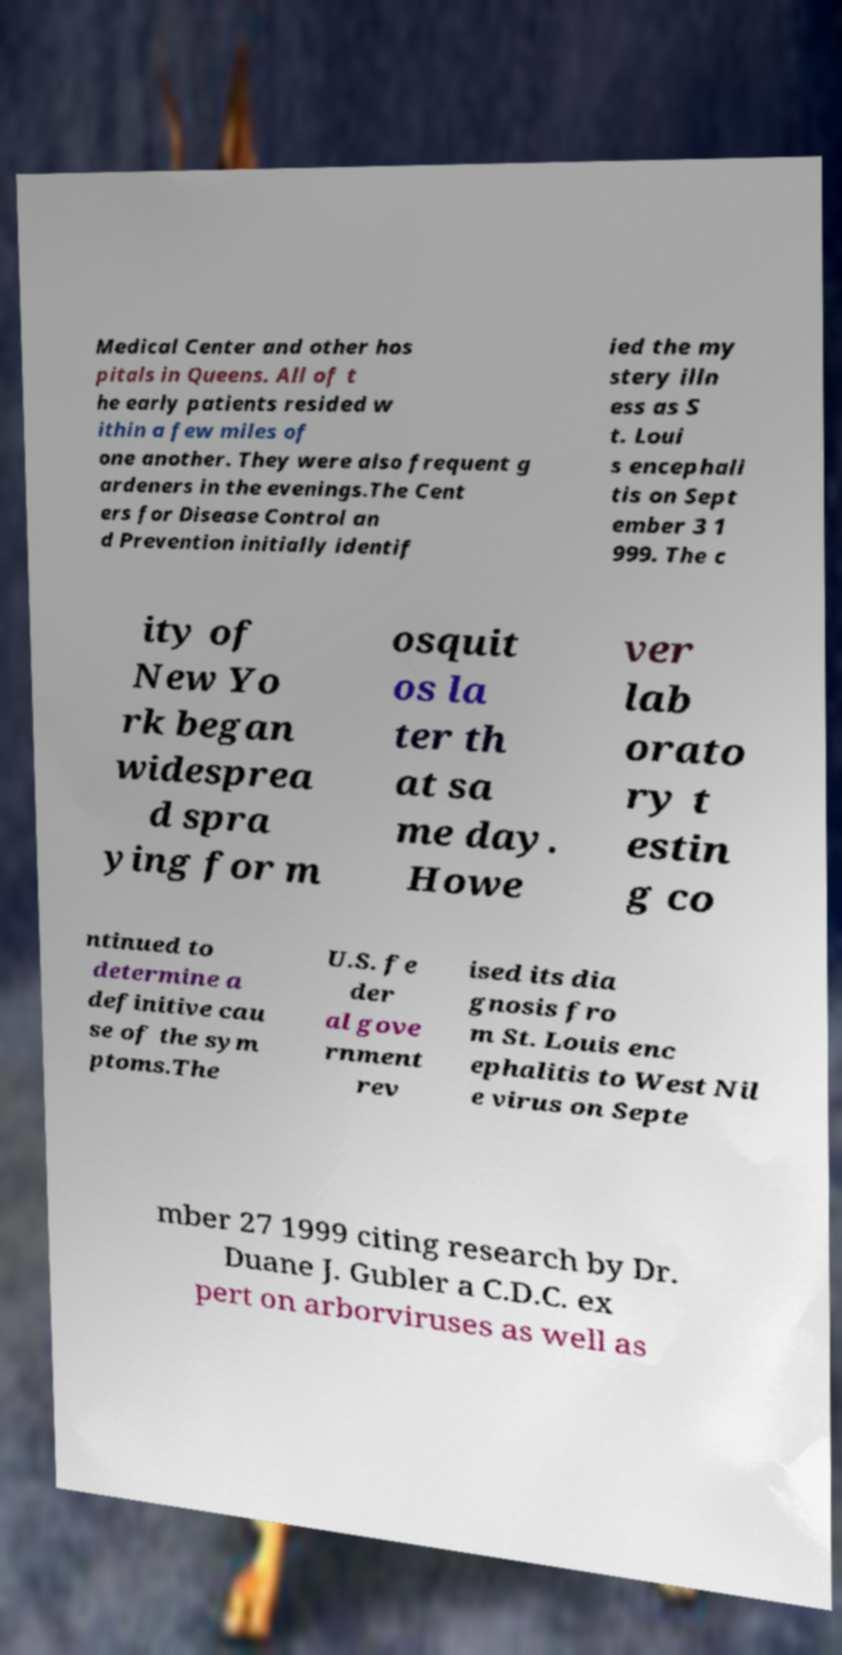For documentation purposes, I need the text within this image transcribed. Could you provide that? Medical Center and other hos pitals in Queens. All of t he early patients resided w ithin a few miles of one another. They were also frequent g ardeners in the evenings.The Cent ers for Disease Control an d Prevention initially identif ied the my stery illn ess as S t. Loui s encephali tis on Sept ember 3 1 999. The c ity of New Yo rk began widesprea d spra ying for m osquit os la ter th at sa me day. Howe ver lab orato ry t estin g co ntinued to determine a definitive cau se of the sym ptoms.The U.S. fe der al gove rnment rev ised its dia gnosis fro m St. Louis enc ephalitis to West Nil e virus on Septe mber 27 1999 citing research by Dr. Duane J. Gubler a C.D.C. ex pert on arborviruses as well as 